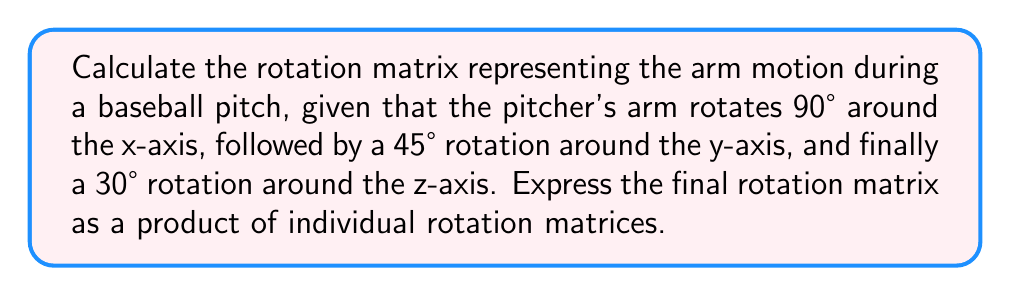Provide a solution to this math problem. To solve this problem, we'll follow these steps:

1) First, let's recall the rotation matrices for rotations around the x, y, and z axes:

   $R_x(\theta) = \begin{pmatrix}
   1 & 0 & 0 \\
   0 & \cos\theta & -\sin\theta \\
   0 & \sin\theta & \cos\theta
   \end{pmatrix}$

   $R_y(\theta) = \begin{pmatrix}
   \cos\theta & 0 & \sin\theta \\
   0 & 1 & 0 \\
   -\sin\theta & 0 & \cos\theta
   \end{pmatrix}$

   $R_z(\theta) = \begin{pmatrix}
   \cos\theta & -\sin\theta & 0 \\
   \sin\theta & \cos\theta & 0 \\
   0 & 0 & 1
   \end{pmatrix}$

2) Now, we'll substitute the given angles:
   - 90° rotation around x-axis: $R_x(90°) = R_x(\frac{\pi}{2})$
   - 45° rotation around y-axis: $R_y(45°) = R_y(\frac{\pi}{4})$
   - 30° rotation around z-axis: $R_z(30°) = R_z(\frac{\pi}{6})$

3) Let's calculate each rotation matrix:

   $R_x(\frac{\pi}{2}) = \begin{pmatrix}
   1 & 0 & 0 \\
   0 & \cos\frac{\pi}{2} & -\sin\frac{\pi}{2} \\
   0 & \sin\frac{\pi}{2} & \cos\frac{\pi}{2}
   \end{pmatrix} = \begin{pmatrix}
   1 & 0 & 0 \\
   0 & 0 & -1 \\
   0 & 1 & 0
   \end{pmatrix}$

   $R_y(\frac{\pi}{4}) = \begin{pmatrix}
   \cos\frac{\pi}{4} & 0 & \sin\frac{\pi}{4} \\
   0 & 1 & 0 \\
   -\sin\frac{\pi}{4} & 0 & \cos\frac{\pi}{4}
   \end{pmatrix} = \begin{pmatrix}
   \frac{\sqrt{2}}{2} & 0 & \frac{\sqrt{2}}{2} \\
   0 & 1 & 0 \\
   -\frac{\sqrt{2}}{2} & 0 & \frac{\sqrt{2}}{2}
   \end{pmatrix}$

   $R_z(\frac{\pi}{6}) = \begin{pmatrix}
   \cos\frac{\pi}{6} & -\sin\frac{\pi}{6} & 0 \\
   \sin\frac{\pi}{6} & \cos\frac{\pi}{6} & 0 \\
   0 & 0 & 1
   \end{pmatrix} = \begin{pmatrix}
   \frac{\sqrt{3}}{2} & -\frac{1}{2} & 0 \\
   \frac{1}{2} & \frac{\sqrt{3}}{2} & 0 \\
   0 & 0 & 1
   \end{pmatrix}$

4) The final rotation matrix is the product of these matrices in the order of rotation:

   $R = R_z(\frac{\pi}{6}) R_y(\frac{\pi}{4}) R_x(\frac{\pi}{2})$

This matrix multiplication represents the complete arm motion during the pitch.
Answer: $R = R_z(\frac{\pi}{6}) R_y(\frac{\pi}{4}) R_x(\frac{\pi}{2}) = \begin{pmatrix}
\frac{\sqrt{3}}{2} & -\frac{1}{2} & 0 \\
\frac{1}{2} & \frac{\sqrt{3}}{2} & 0 \\
0 & 0 & 1
\end{pmatrix} \begin{pmatrix}
\frac{\sqrt{2}}{2} & 0 & \frac{\sqrt{2}}{2} \\
0 & 1 & 0 \\
-\frac{\sqrt{2}}{2} & 0 & \frac{\sqrt{2}}{2}
\end{pmatrix} \begin{pmatrix}
1 & 0 & 0 \\
0 & 0 & -1 \\
0 & 1 & 0
\end{pmatrix}$ 